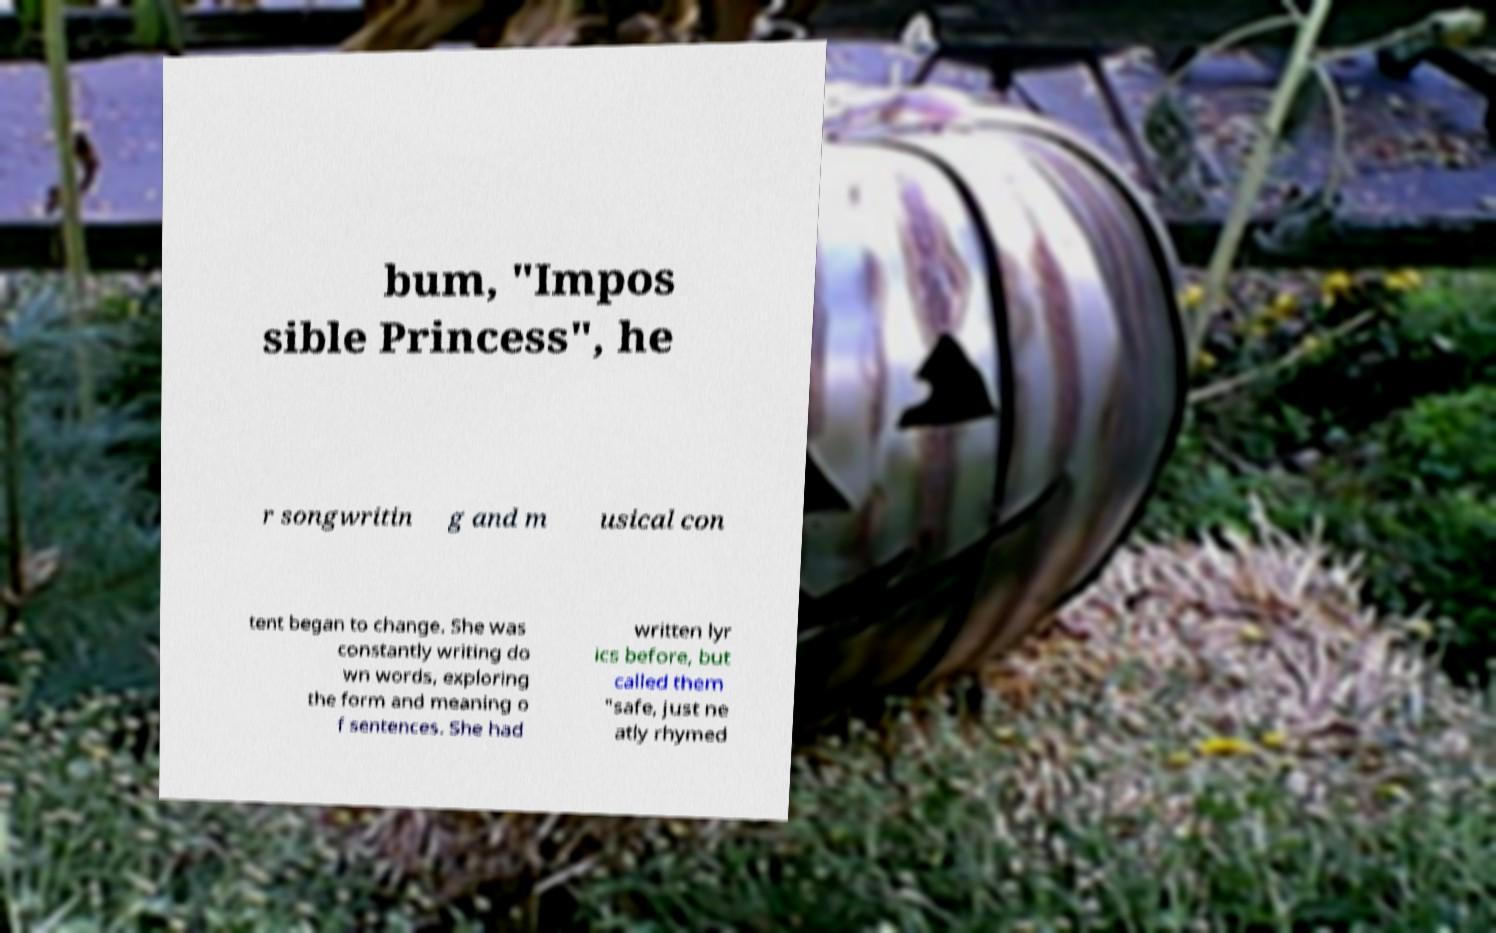Can you read and provide the text displayed in the image?This photo seems to have some interesting text. Can you extract and type it out for me? bum, "Impos sible Princess", he r songwritin g and m usical con tent began to change. She was constantly writing do wn words, exploring the form and meaning o f sentences. She had written lyr ics before, but called them "safe, just ne atly rhymed 